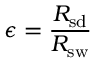Convert formula to latex. <formula><loc_0><loc_0><loc_500><loc_500>\epsilon = { \frac { R _ { s d } } { R _ { s w } } }</formula> 